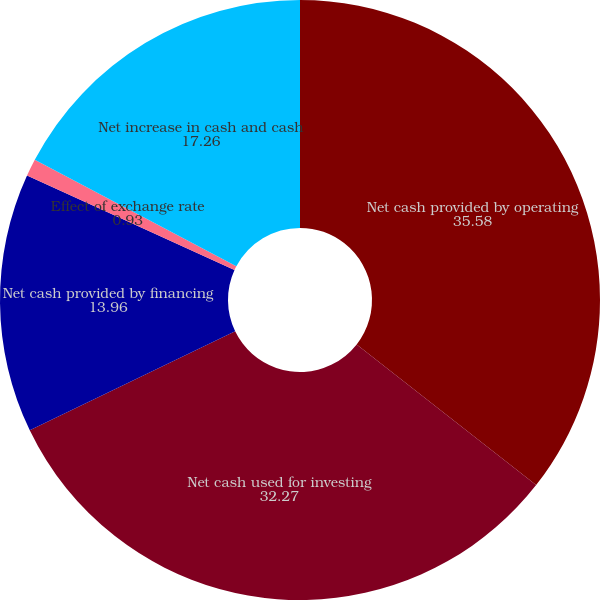<chart> <loc_0><loc_0><loc_500><loc_500><pie_chart><fcel>Net cash provided by operating<fcel>Net cash used for investing<fcel>Net cash provided by financing<fcel>Effect of exchange rate<fcel>Net increase in cash and cash<nl><fcel>35.58%<fcel>32.27%<fcel>13.96%<fcel>0.93%<fcel>17.26%<nl></chart> 